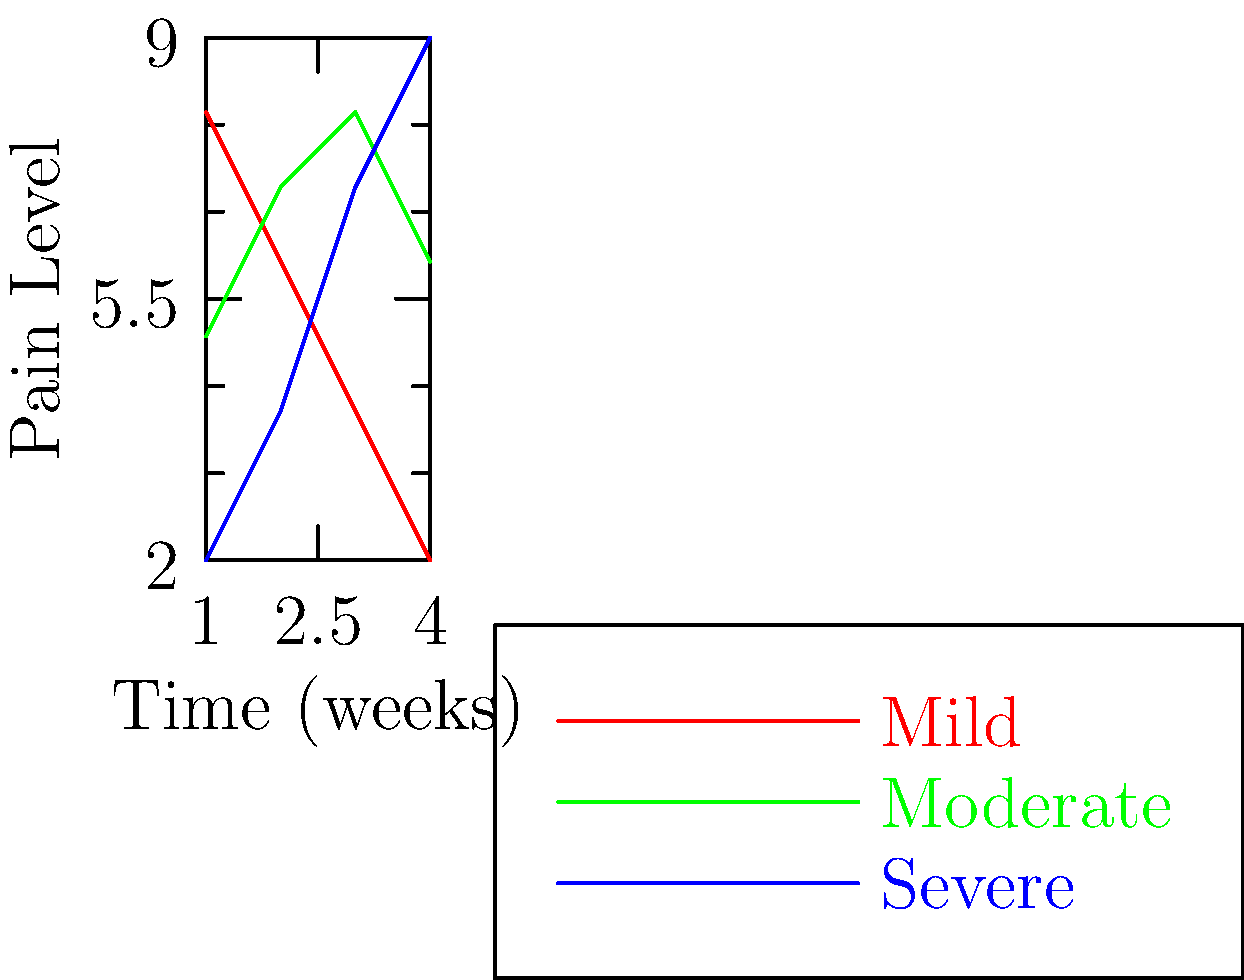Based on the graph showing pain levels over time for different severities of anal fissures, which type of fissure typically shows a consistent increase in pain level over the 4-week period? To answer this question, we need to analyze the trends of each line in the graph:

1. The red line, representing mild fissures, shows a decreasing trend in pain level over time.
2. The green line, representing moderate fissures, shows fluctuations but no consistent increase.
3. The blue line, representing severe fissures, shows a clear and consistent increase in pain level from week 1 to week 4.

By observing these trends, we can conclude that severe anal fissures typically show a consistent increase in pain level over the 4-week period.

This information is crucial for a supportive friend to understand the potential pain progression and recovery timeline for different severities of anal fissures. It can help in providing appropriate emotional support and encouraging timely medical intervention if needed.
Answer: Severe 